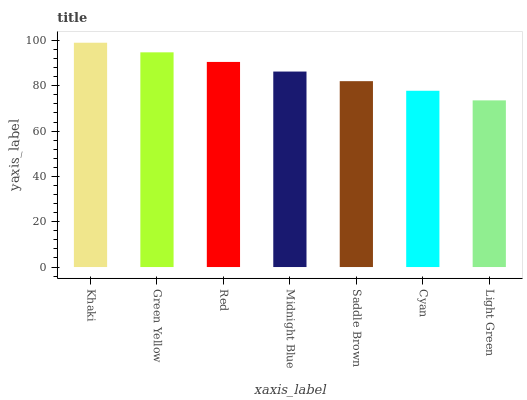Is Light Green the minimum?
Answer yes or no. Yes. Is Khaki the maximum?
Answer yes or no. Yes. Is Green Yellow the minimum?
Answer yes or no. No. Is Green Yellow the maximum?
Answer yes or no. No. Is Khaki greater than Green Yellow?
Answer yes or no. Yes. Is Green Yellow less than Khaki?
Answer yes or no. Yes. Is Green Yellow greater than Khaki?
Answer yes or no. No. Is Khaki less than Green Yellow?
Answer yes or no. No. Is Midnight Blue the high median?
Answer yes or no. Yes. Is Midnight Blue the low median?
Answer yes or no. Yes. Is Light Green the high median?
Answer yes or no. No. Is Green Yellow the low median?
Answer yes or no. No. 